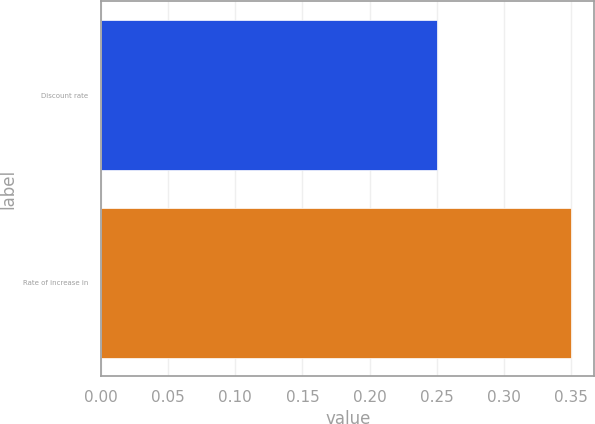Convert chart to OTSL. <chart><loc_0><loc_0><loc_500><loc_500><bar_chart><fcel>Discount rate<fcel>Rate of increase in<nl><fcel>0.25<fcel>0.35<nl></chart> 